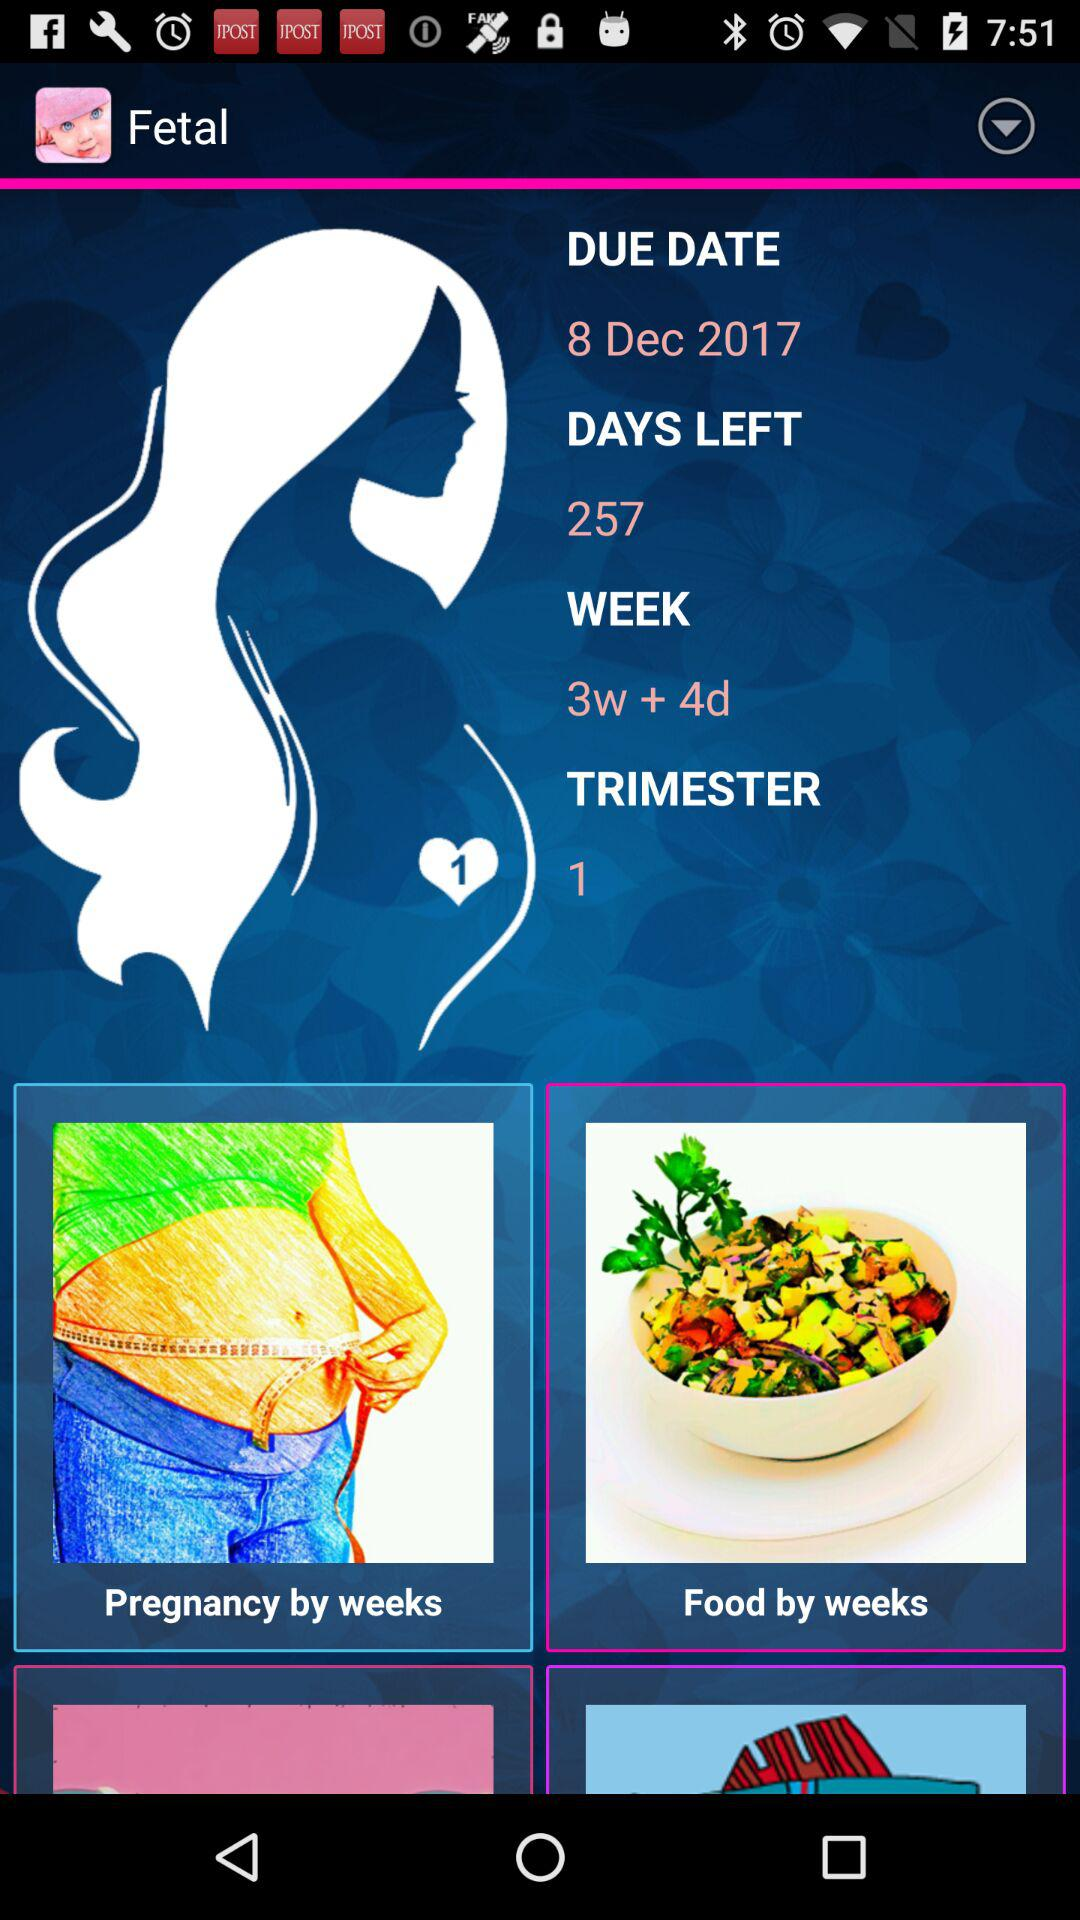What is the trimester of the pregnancy?
Answer the question using a single word or phrase. 1 